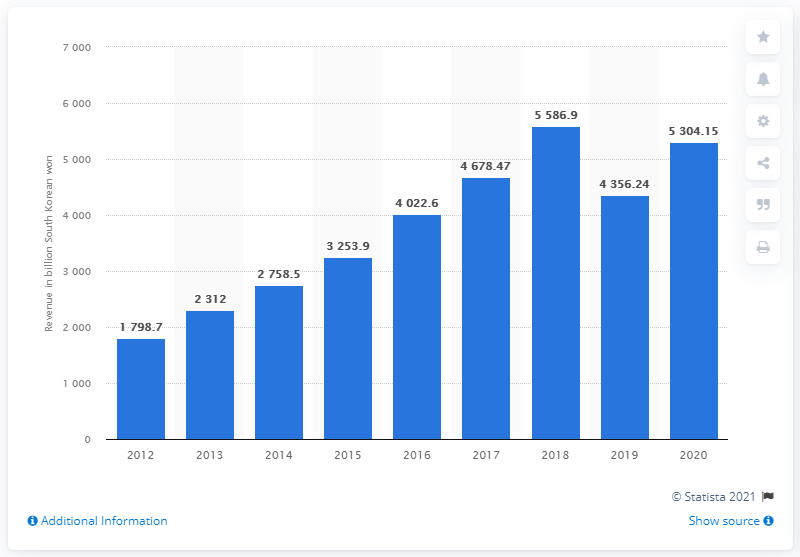Give some essential details in this illustration. Naver Corporation's revenue in 2020 was 5304.15 million. 